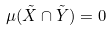Convert formula to latex. <formula><loc_0><loc_0><loc_500><loc_500>\mu ( \tilde { X } \cap \tilde { Y } ) = 0</formula> 